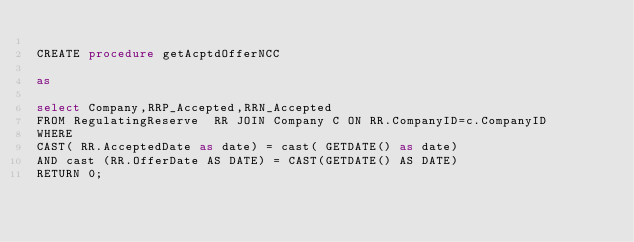<code> <loc_0><loc_0><loc_500><loc_500><_SQL_>
CREATE procedure getAcptdOfferNCC

as

select Company,RRP_Accepted,RRN_Accepted
FROM RegulatingReserve  RR JOIN Company C ON RR.CompanyID=c.CompanyID
WHERE 
CAST( RR.AcceptedDate as date) = cast( GETDATE() as date) 
AND cast (RR.OfferDate AS DATE) = CAST(GETDATE() AS DATE)
RETURN 0;
</code> 